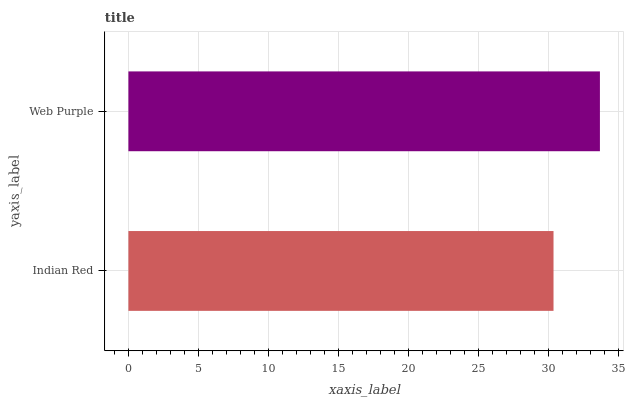Is Indian Red the minimum?
Answer yes or no. Yes. Is Web Purple the maximum?
Answer yes or no. Yes. Is Web Purple the minimum?
Answer yes or no. No. Is Web Purple greater than Indian Red?
Answer yes or no. Yes. Is Indian Red less than Web Purple?
Answer yes or no. Yes. Is Indian Red greater than Web Purple?
Answer yes or no. No. Is Web Purple less than Indian Red?
Answer yes or no. No. Is Web Purple the high median?
Answer yes or no. Yes. Is Indian Red the low median?
Answer yes or no. Yes. Is Indian Red the high median?
Answer yes or no. No. Is Web Purple the low median?
Answer yes or no. No. 